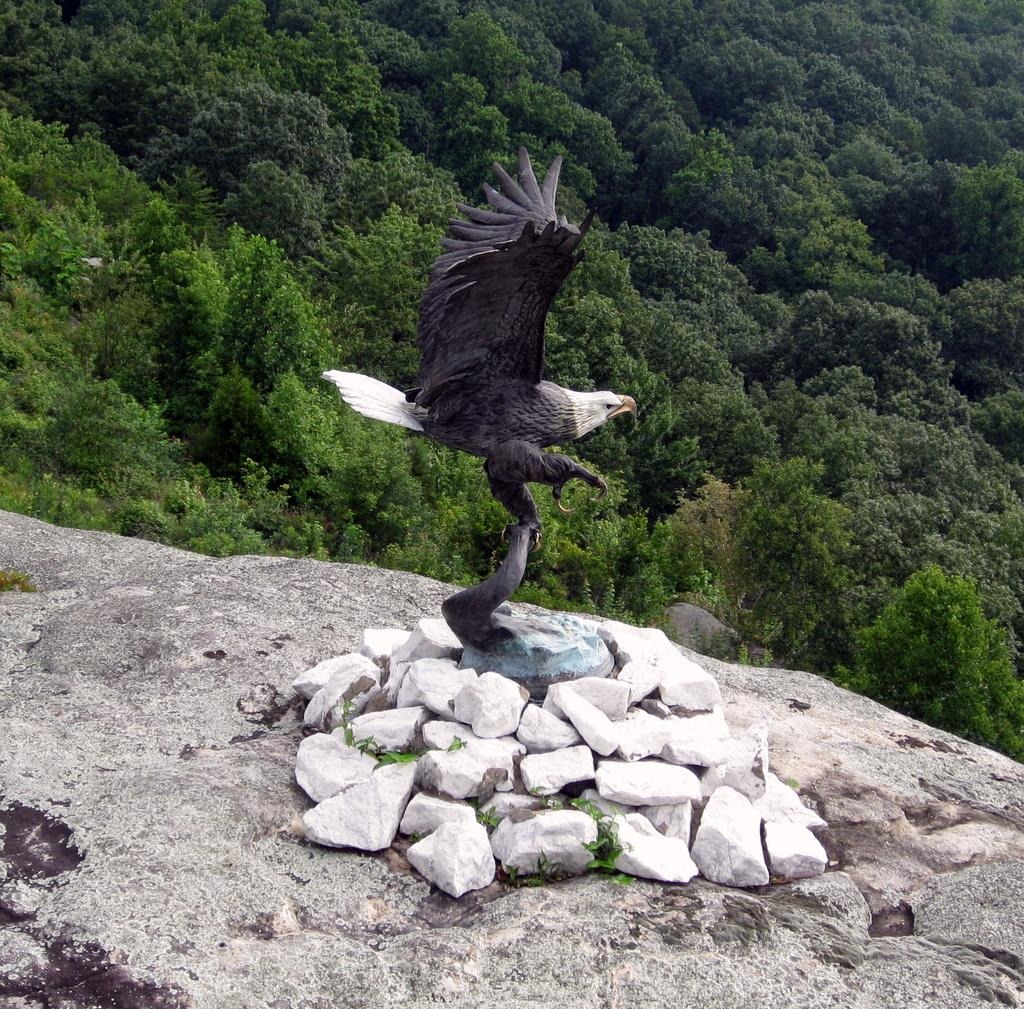What type of animals can be seen in the image? There are birds in the image. What objects are present in the image? There are stones in the image. What can be seen in the background of the image? There are trees in the background of the image. What type of hair can be seen on the birds in the image? There is no hair present on the birds in the image; birds have feathers, not hair. 